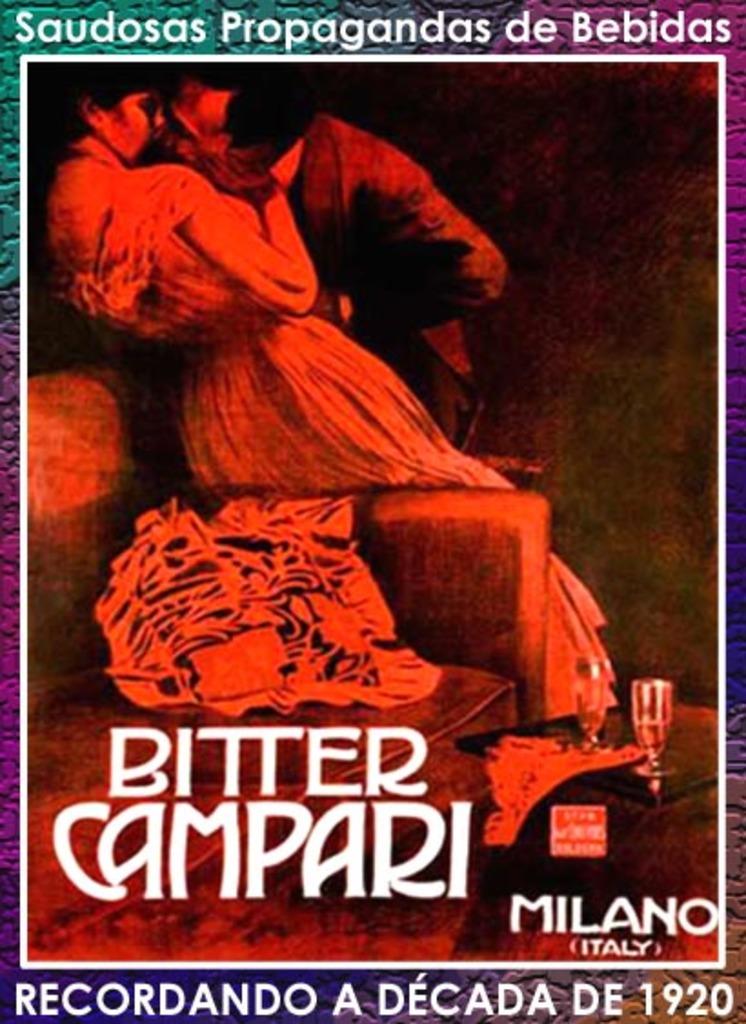What country is mentioned on the poster?
Your response must be concise. Italy. 